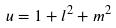<formula> <loc_0><loc_0><loc_500><loc_500>u = 1 + l ^ { 2 } + m ^ { 2 }</formula> 